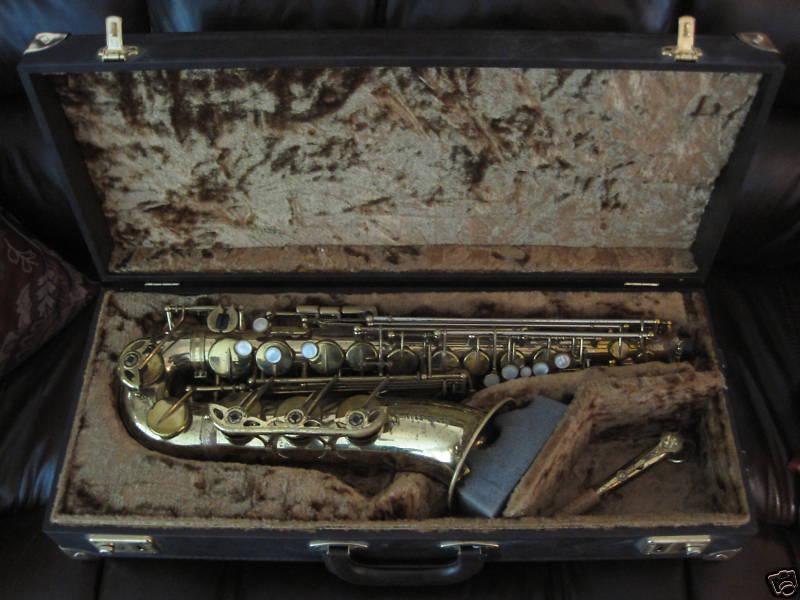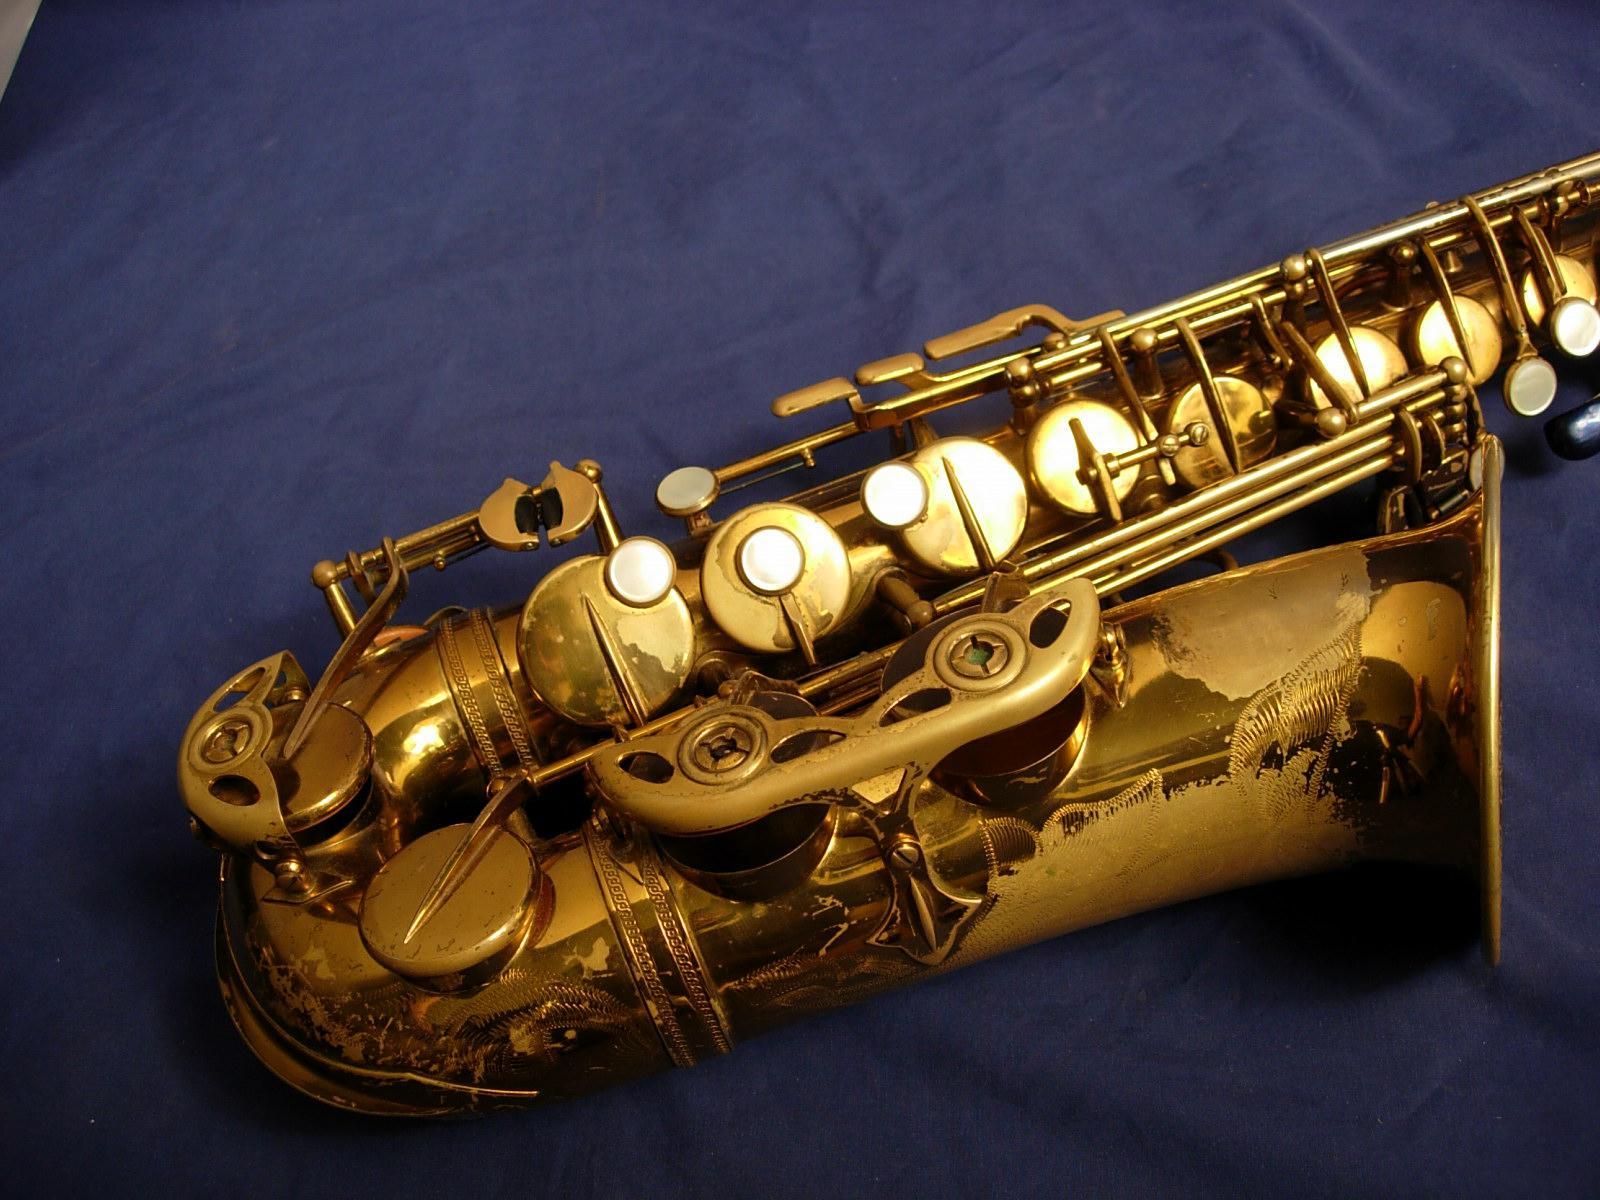The first image is the image on the left, the second image is the image on the right. Evaluate the accuracy of this statement regarding the images: "One image shows a saxophone with a curved bell end that has its mouthpiece separate and lying near the saxophone's bell.". Is it true? Answer yes or no. Yes. 